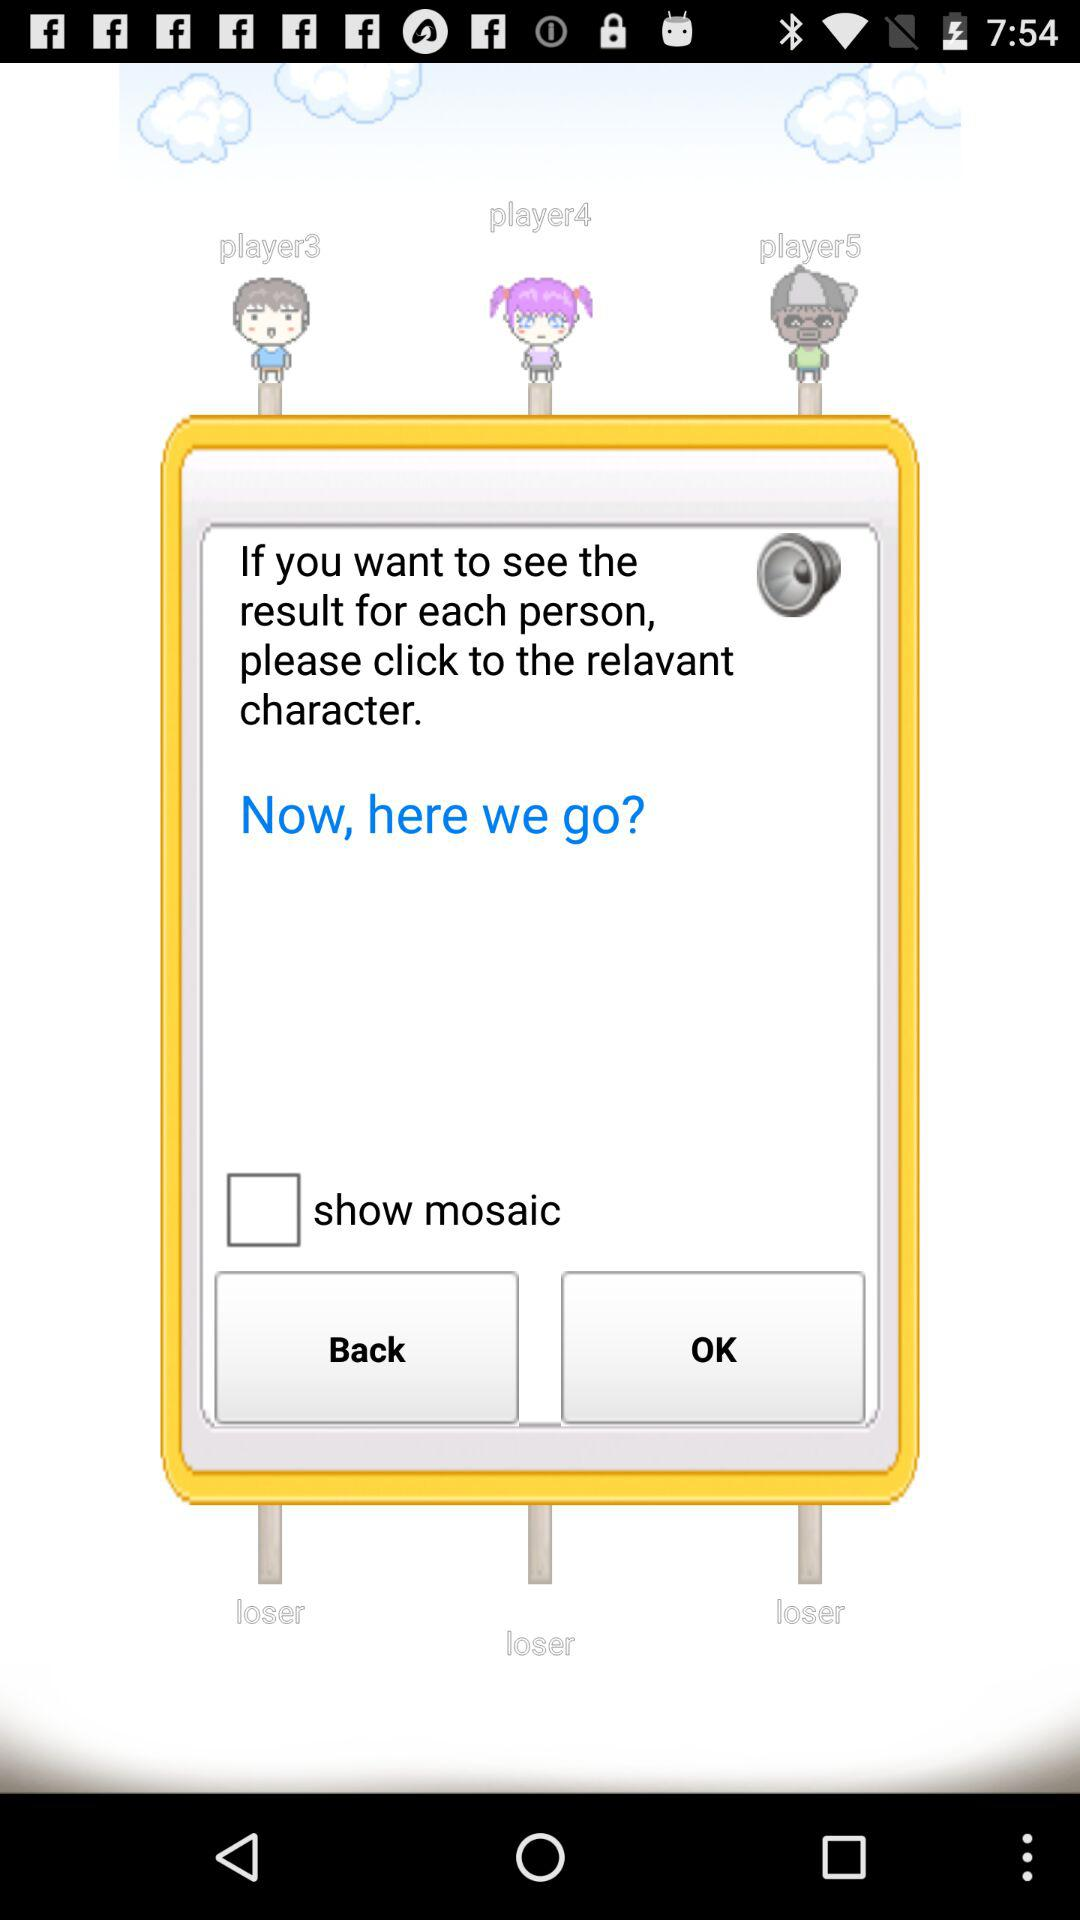What's the status of the "show mosaic"? The status of the "show mosaic" is "off". 